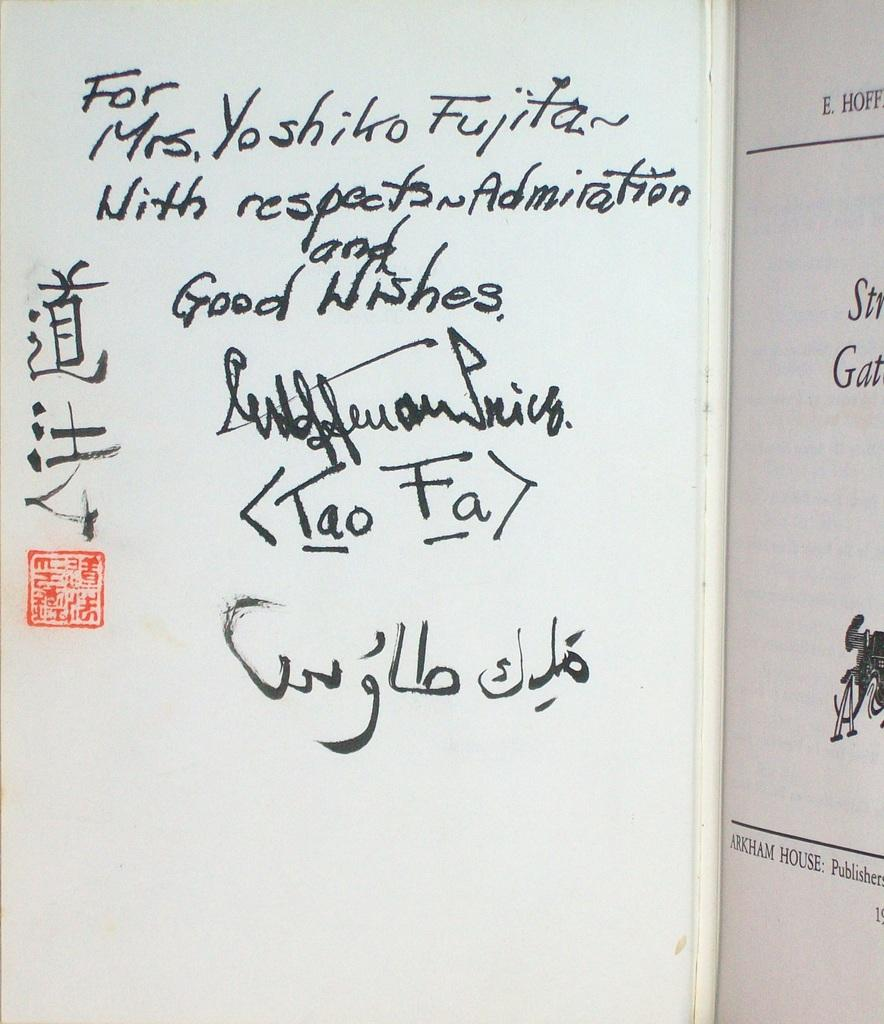<image>
Share a concise interpretation of the image provided. the word tao is on a white board 